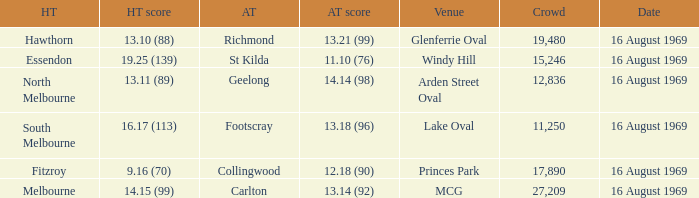Who was home at Princes Park? 9.16 (70). 